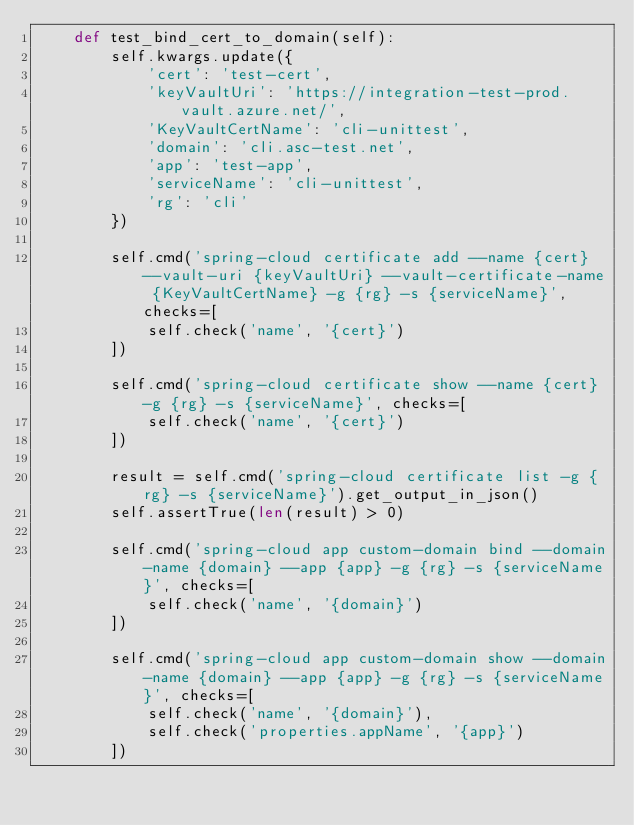<code> <loc_0><loc_0><loc_500><loc_500><_Python_>    def test_bind_cert_to_domain(self):
        self.kwargs.update({
            'cert': 'test-cert',
            'keyVaultUri': 'https://integration-test-prod.vault.azure.net/',
            'KeyVaultCertName': 'cli-unittest',
            'domain': 'cli.asc-test.net',
            'app': 'test-app',
            'serviceName': 'cli-unittest',
            'rg': 'cli'
        })

        self.cmd('spring-cloud certificate add --name {cert} --vault-uri {keyVaultUri} --vault-certificate-name {KeyVaultCertName} -g {rg} -s {serviceName}', checks=[
            self.check('name', '{cert}')
        ])

        self.cmd('spring-cloud certificate show --name {cert} -g {rg} -s {serviceName}', checks=[
            self.check('name', '{cert}')
        ])

        result = self.cmd('spring-cloud certificate list -g {rg} -s {serviceName}').get_output_in_json()
        self.assertTrue(len(result) > 0)

        self.cmd('spring-cloud app custom-domain bind --domain-name {domain} --app {app} -g {rg} -s {serviceName}', checks=[
            self.check('name', '{domain}')
        ])

        self.cmd('spring-cloud app custom-domain show --domain-name {domain} --app {app} -g {rg} -s {serviceName}', checks=[
            self.check('name', '{domain}'),
            self.check('properties.appName', '{app}')
        ])
</code> 